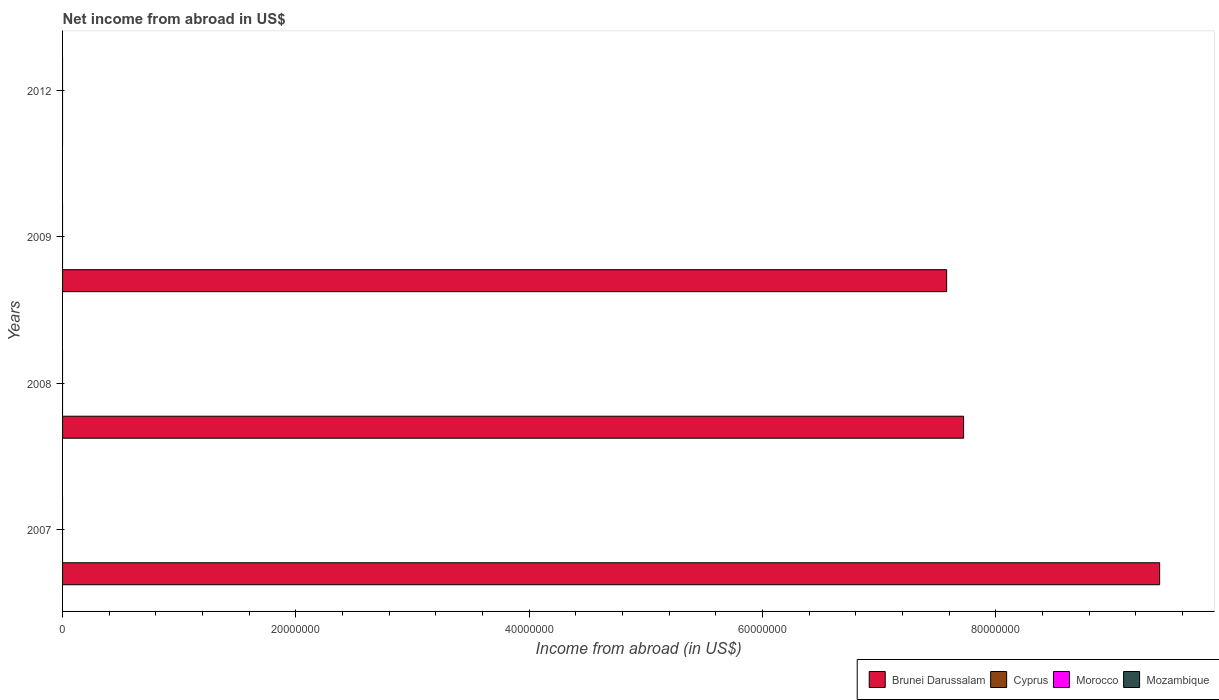How many different coloured bars are there?
Provide a succinct answer. 1. Are the number of bars on each tick of the Y-axis equal?
Your response must be concise. No. How many bars are there on the 2nd tick from the top?
Your answer should be very brief. 1. What is the label of the 2nd group of bars from the top?
Ensure brevity in your answer.  2009. Across all years, what is the maximum net income from abroad in Brunei Darussalam?
Provide a succinct answer. 9.40e+07. Across all years, what is the minimum net income from abroad in Cyprus?
Your response must be concise. 0. In which year was the net income from abroad in Brunei Darussalam maximum?
Provide a short and direct response. 2007. What is the difference between the net income from abroad in Cyprus in 2009 and the net income from abroad in Brunei Darussalam in 2007?
Give a very brief answer. -9.40e+07. What is the average net income from abroad in Cyprus per year?
Offer a very short reply. 0. What is the ratio of the net income from abroad in Brunei Darussalam in 2008 to that in 2009?
Ensure brevity in your answer.  1.02. What is the difference between the highest and the second highest net income from abroad in Brunei Darussalam?
Your response must be concise. 1.68e+07. What is the difference between the highest and the lowest net income from abroad in Brunei Darussalam?
Your answer should be compact. 9.40e+07. Is the sum of the net income from abroad in Brunei Darussalam in 2007 and 2009 greater than the maximum net income from abroad in Cyprus across all years?
Your response must be concise. Yes. Is it the case that in every year, the sum of the net income from abroad in Morocco and net income from abroad in Brunei Darussalam is greater than the net income from abroad in Mozambique?
Offer a very short reply. No. Are all the bars in the graph horizontal?
Provide a short and direct response. Yes. What is the difference between two consecutive major ticks on the X-axis?
Provide a succinct answer. 2.00e+07. Are the values on the major ticks of X-axis written in scientific E-notation?
Your answer should be compact. No. Does the graph contain any zero values?
Offer a very short reply. Yes. Does the graph contain grids?
Make the answer very short. No. How many legend labels are there?
Offer a very short reply. 4. What is the title of the graph?
Make the answer very short. Net income from abroad in US$. Does "High income: OECD" appear as one of the legend labels in the graph?
Give a very brief answer. No. What is the label or title of the X-axis?
Keep it short and to the point. Income from abroad (in US$). What is the label or title of the Y-axis?
Your answer should be very brief. Years. What is the Income from abroad (in US$) of Brunei Darussalam in 2007?
Your answer should be compact. 9.40e+07. What is the Income from abroad (in US$) of Cyprus in 2007?
Your response must be concise. 0. What is the Income from abroad (in US$) of Morocco in 2007?
Offer a very short reply. 0. What is the Income from abroad (in US$) in Brunei Darussalam in 2008?
Offer a terse response. 7.72e+07. What is the Income from abroad (in US$) of Cyprus in 2008?
Your answer should be compact. 0. What is the Income from abroad (in US$) of Mozambique in 2008?
Give a very brief answer. 0. What is the Income from abroad (in US$) in Brunei Darussalam in 2009?
Make the answer very short. 7.58e+07. What is the Income from abroad (in US$) in Morocco in 2009?
Your response must be concise. 0. What is the Income from abroad (in US$) of Mozambique in 2009?
Give a very brief answer. 0. What is the Income from abroad (in US$) of Brunei Darussalam in 2012?
Provide a succinct answer. 0. What is the Income from abroad (in US$) in Morocco in 2012?
Keep it short and to the point. 0. What is the Income from abroad (in US$) in Mozambique in 2012?
Your answer should be very brief. 0. Across all years, what is the maximum Income from abroad (in US$) in Brunei Darussalam?
Give a very brief answer. 9.40e+07. Across all years, what is the minimum Income from abroad (in US$) of Brunei Darussalam?
Your response must be concise. 0. What is the total Income from abroad (in US$) of Brunei Darussalam in the graph?
Offer a terse response. 2.47e+08. What is the total Income from abroad (in US$) of Mozambique in the graph?
Provide a short and direct response. 0. What is the difference between the Income from abroad (in US$) in Brunei Darussalam in 2007 and that in 2008?
Your response must be concise. 1.68e+07. What is the difference between the Income from abroad (in US$) in Brunei Darussalam in 2007 and that in 2009?
Ensure brevity in your answer.  1.83e+07. What is the difference between the Income from abroad (in US$) in Brunei Darussalam in 2008 and that in 2009?
Provide a succinct answer. 1.45e+06. What is the average Income from abroad (in US$) of Brunei Darussalam per year?
Your answer should be compact. 6.18e+07. What is the average Income from abroad (in US$) of Morocco per year?
Offer a very short reply. 0. What is the average Income from abroad (in US$) of Mozambique per year?
Offer a terse response. 0. What is the ratio of the Income from abroad (in US$) of Brunei Darussalam in 2007 to that in 2008?
Keep it short and to the point. 1.22. What is the ratio of the Income from abroad (in US$) in Brunei Darussalam in 2007 to that in 2009?
Make the answer very short. 1.24. What is the ratio of the Income from abroad (in US$) of Brunei Darussalam in 2008 to that in 2009?
Your response must be concise. 1.02. What is the difference between the highest and the second highest Income from abroad (in US$) of Brunei Darussalam?
Offer a terse response. 1.68e+07. What is the difference between the highest and the lowest Income from abroad (in US$) of Brunei Darussalam?
Your response must be concise. 9.40e+07. 